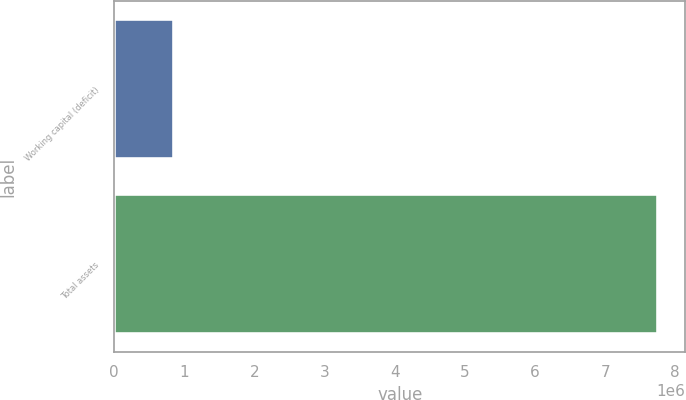<chart> <loc_0><loc_0><loc_500><loc_500><bar_chart><fcel>Working capital (deficit)<fcel>Total assets<nl><fcel>847981<fcel>7.75689e+06<nl></chart> 